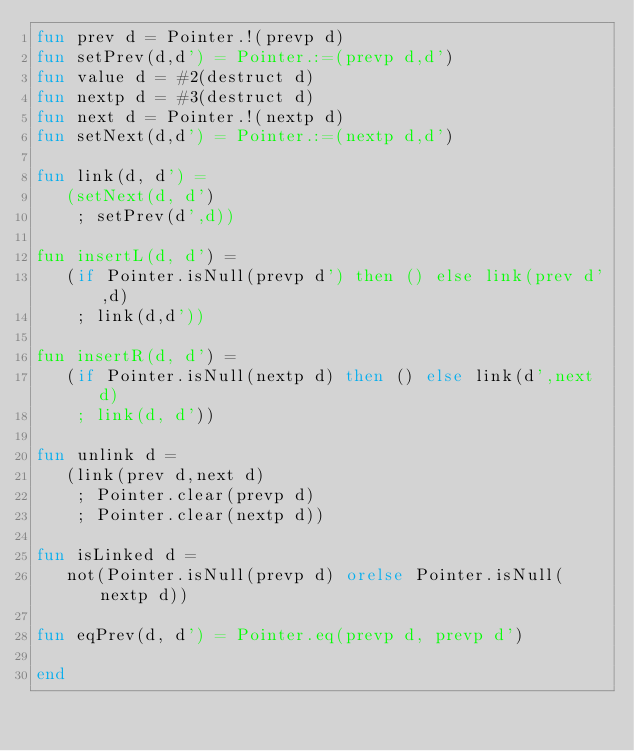Convert code to text. <code><loc_0><loc_0><loc_500><loc_500><_SML_>fun prev d = Pointer.!(prevp d)
fun setPrev(d,d') = Pointer.:=(prevp d,d')
fun value d = #2(destruct d)
fun nextp d = #3(destruct d)
fun next d = Pointer.!(nextp d)
fun setNext(d,d') = Pointer.:=(nextp d,d')

fun link(d, d') =
   (setNext(d, d')
    ; setPrev(d',d))

fun insertL(d, d') =
   (if Pointer.isNull(prevp d') then () else link(prev d',d)
    ; link(d,d'))

fun insertR(d, d') =
   (if Pointer.isNull(nextp d) then () else link(d',next d)
    ; link(d, d'))

fun unlink d =
   (link(prev d,next d)
    ; Pointer.clear(prevp d)
    ; Pointer.clear(nextp d))

fun isLinked d =
   not(Pointer.isNull(prevp d) orelse Pointer.isNull(nextp d))

fun eqPrev(d, d') = Pointer.eq(prevp d, prevp d')

end
</code> 